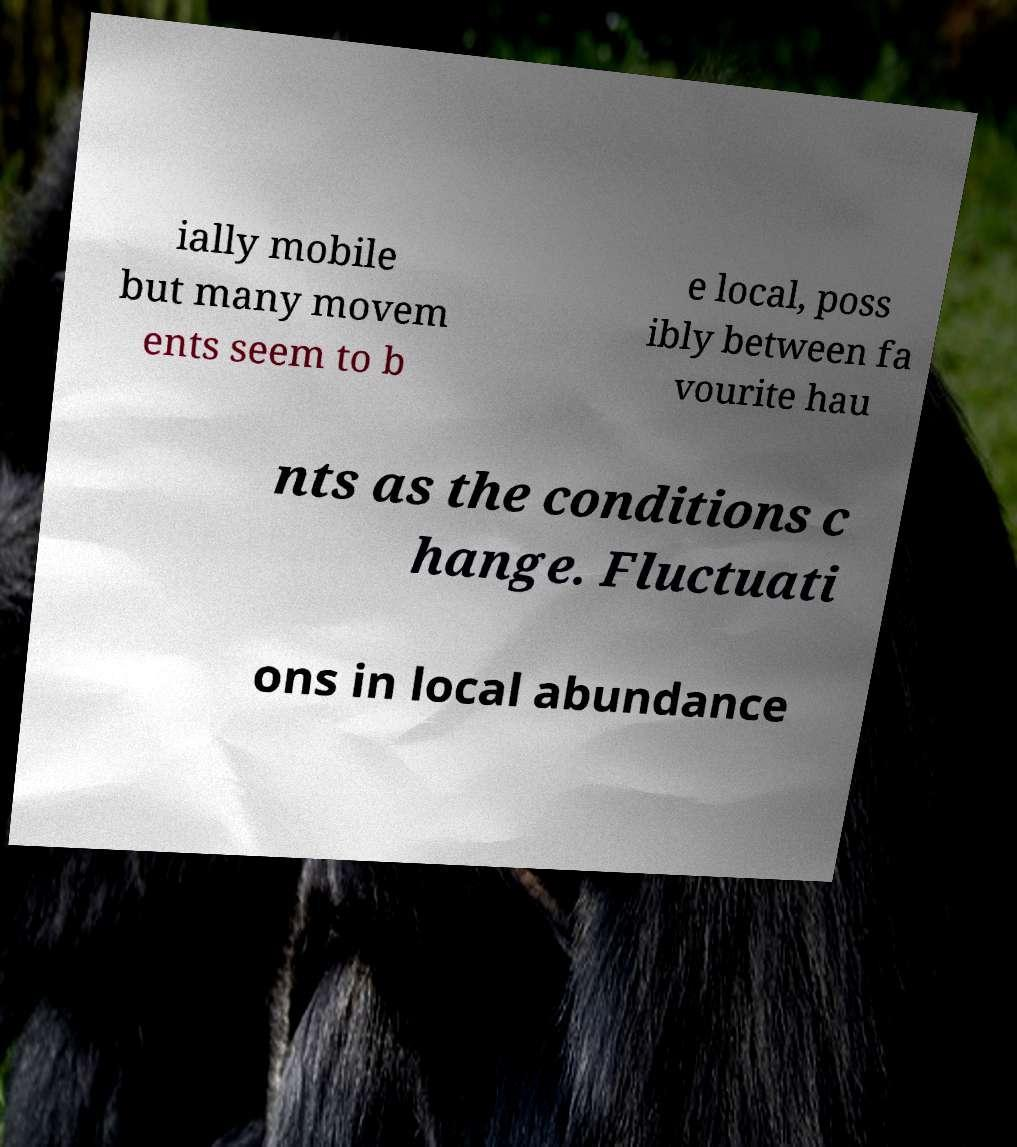I need the written content from this picture converted into text. Can you do that? ially mobile but many movem ents seem to b e local, poss ibly between fa vourite hau nts as the conditions c hange. Fluctuati ons in local abundance 